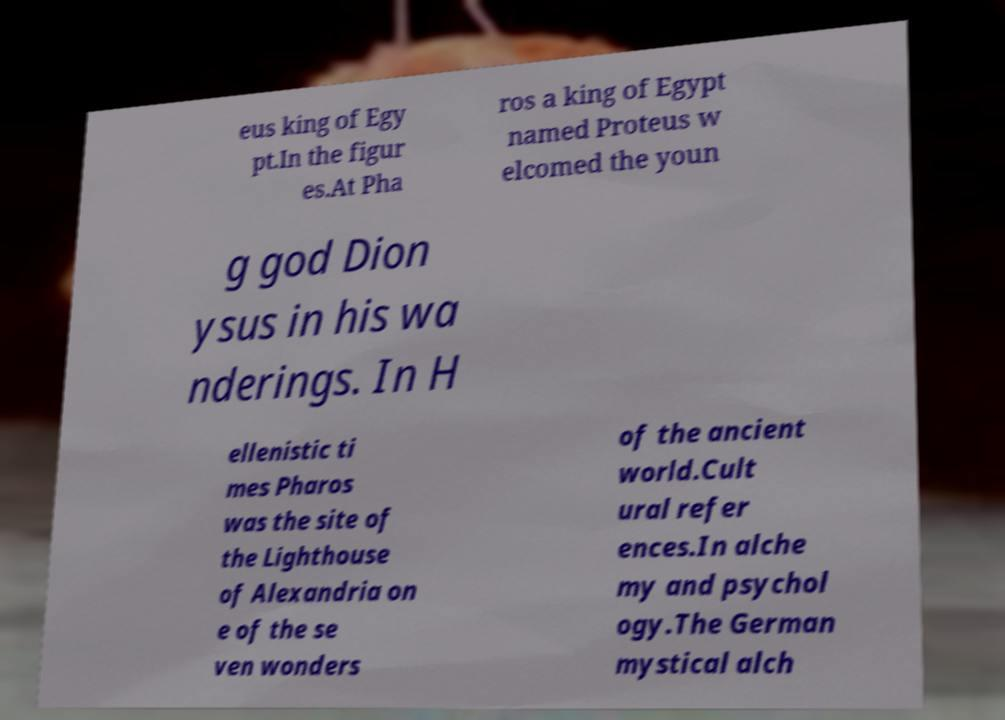What messages or text are displayed in this image? I need them in a readable, typed format. eus king of Egy pt.In the figur es.At Pha ros a king of Egypt named Proteus w elcomed the youn g god Dion ysus in his wa nderings. In H ellenistic ti mes Pharos was the site of the Lighthouse of Alexandria on e of the se ven wonders of the ancient world.Cult ural refer ences.In alche my and psychol ogy.The German mystical alch 